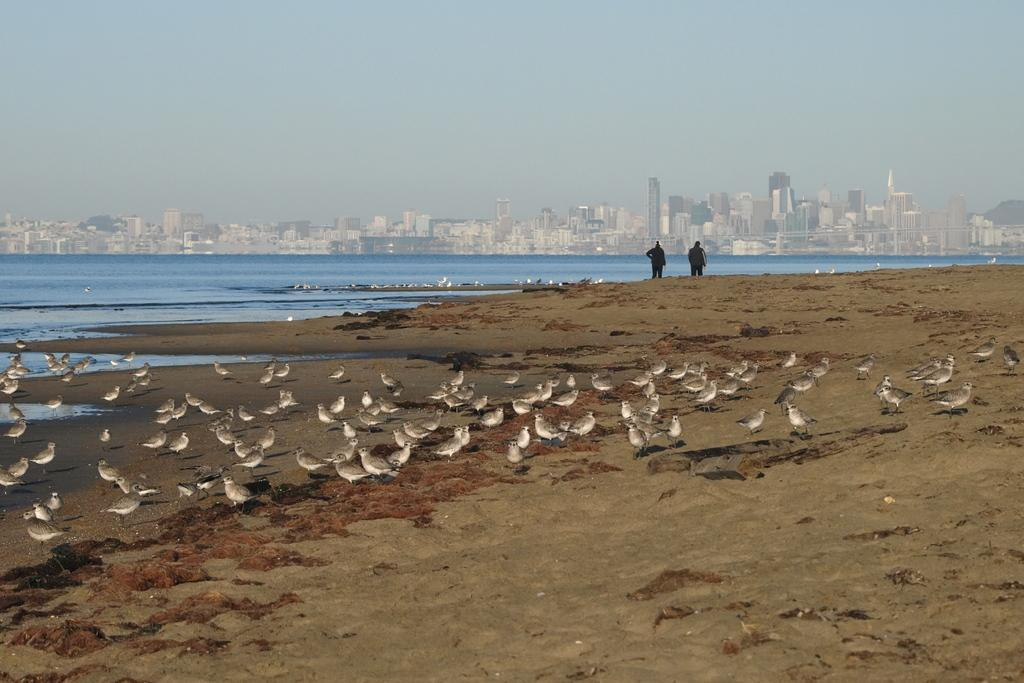What is the location of the persons in the image? The persons are standing on the seashore. What type of animals can be seen in the image? There are birds visible in the image. What natural feature is present in the image? The sea is present in the image. What type of structures can be seen in the image? There are buildings and skyscrapers visible in the image. What part of the natural environment is visible in the image? The sky is visible in the image. Can you tell me how much the journey cost, as mentioned on the receipt in the image? There is no receipt or mention of a journey in the image; it features persons standing on the seashore, birds, the sea, buildings, skyscrapers, and the sky. What type of punishment is being administered to the person in the image? There is no person being punished in the image; it features persons standing on the seashore, birds, the sea, buildings, skyscrapers, and the sky. 